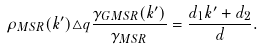Convert formula to latex. <formula><loc_0><loc_0><loc_500><loc_500>\rho _ { M S R } ( k ^ { \prime } ) \triangle q \frac { \gamma _ { G M S R } ( k ^ { \prime } ) } { \gamma _ { M S R } } = \frac { d _ { 1 } k ^ { \prime } + d _ { 2 } } { d } .</formula> 